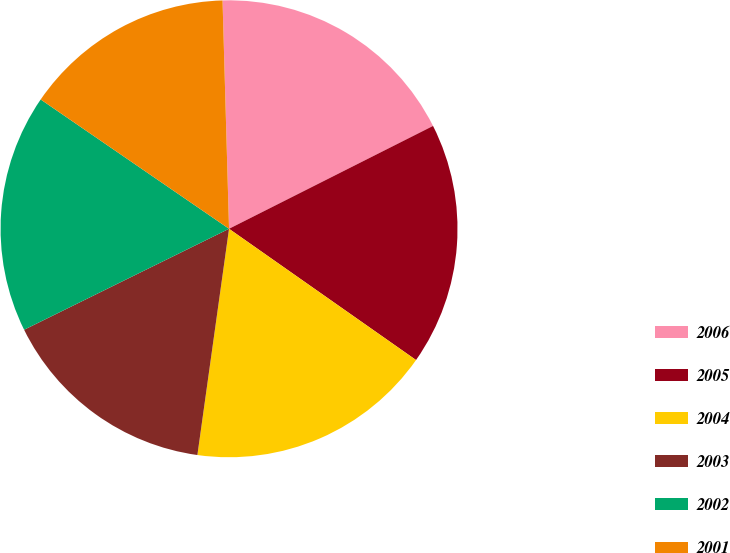<chart> <loc_0><loc_0><loc_500><loc_500><pie_chart><fcel>2006<fcel>2005<fcel>2004<fcel>2003<fcel>2002<fcel>2001<nl><fcel>18.02%<fcel>17.17%<fcel>17.47%<fcel>15.5%<fcel>16.86%<fcel>14.97%<nl></chart> 